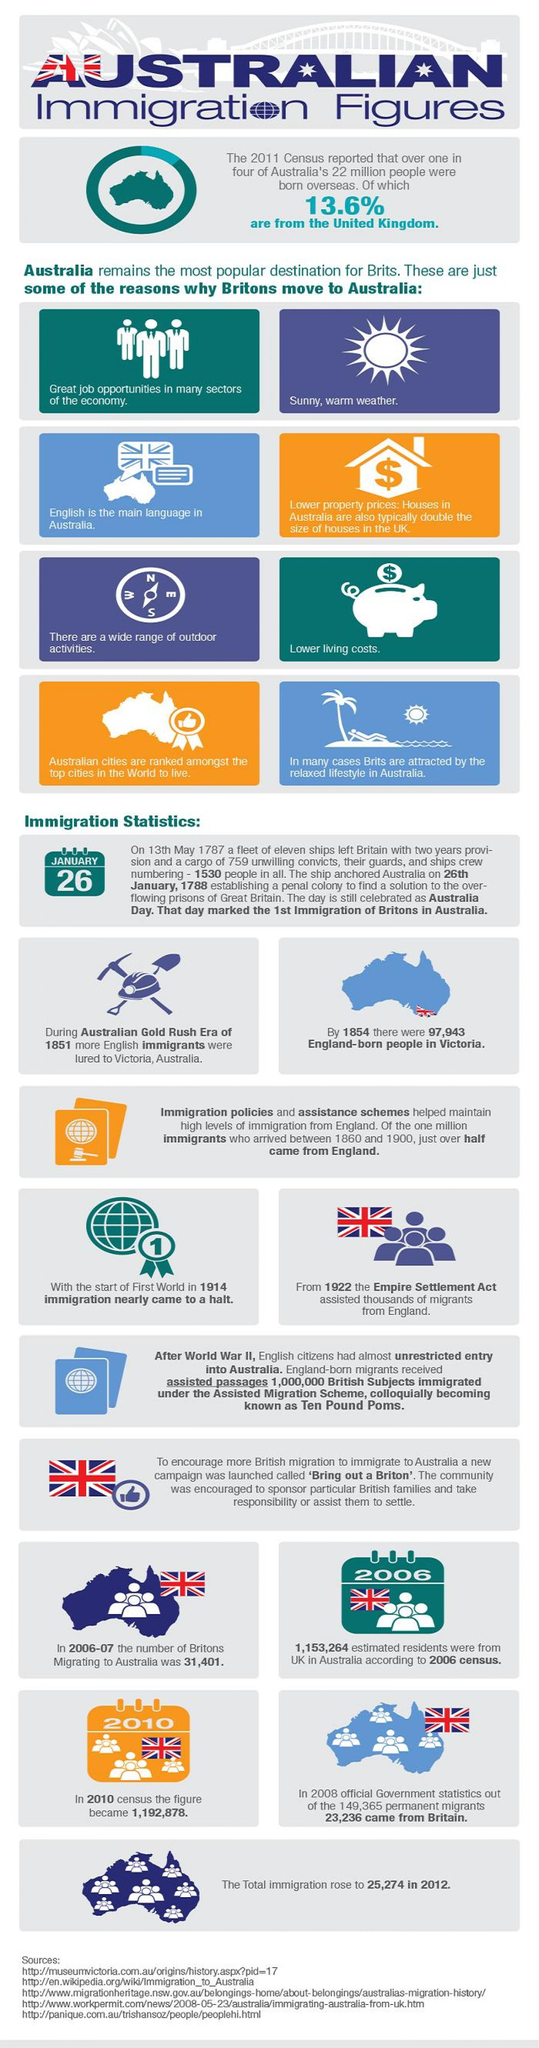Highlight a few significant elements in this photo. The Gold Rush Era of Australia occurred in 1851. There are eight reasons that have been listed to demonstrate why Britons move to Australia. The immigration to Australia came closer to an abrupt stop in 1914. According to recent data, approximately 86.4% of Australians who were born overseas are not from the United Kingdom. The migration of more people born in England to Australia occurred in the year 1854. 